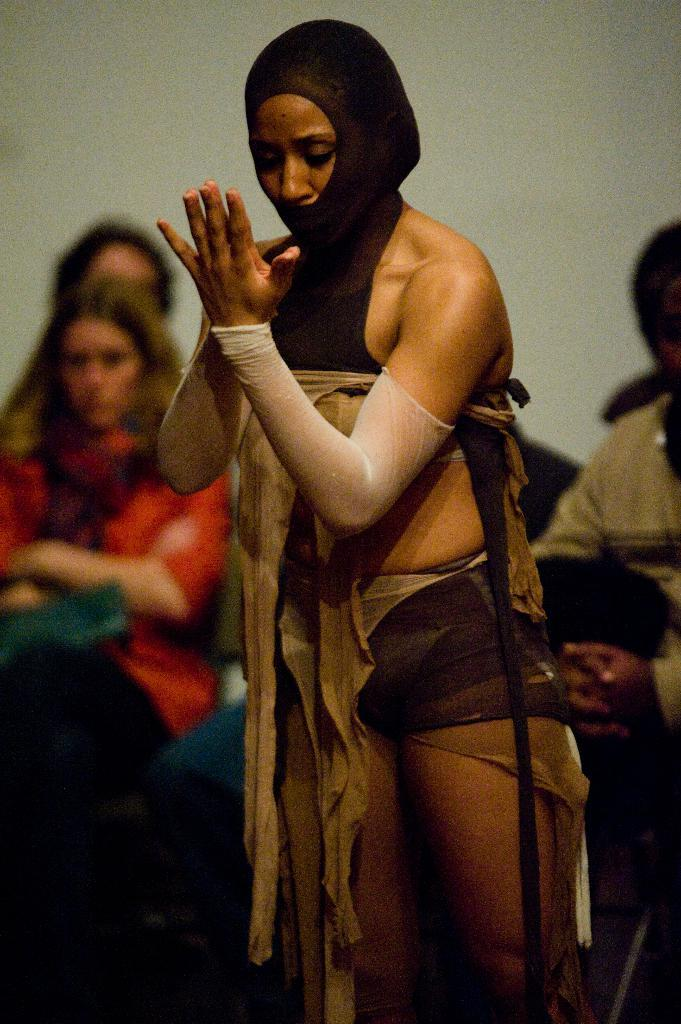What is the primary action of the woman in the image? The woman is standing in the image. What are the other people in the image doing? There are people sitting in the image. What might the people be holding in their hands? The people are holding bags in the image. What type of rhythm can be heard coming from the volcano in the image? There is no volcano present in the image, so it is not possible to determine what, if any, rhythm might be heard. 